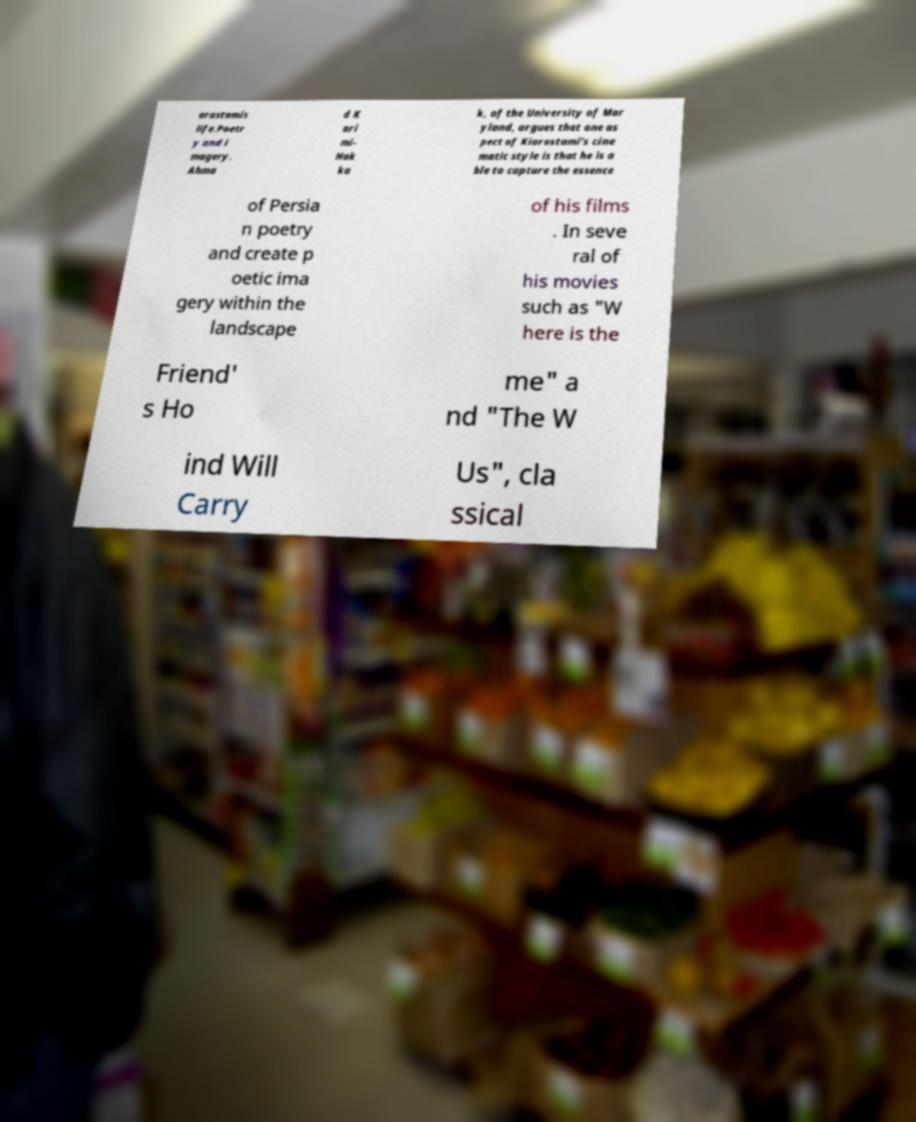Please identify and transcribe the text found in this image. arostamis life.Poetr y and i magery. Ahma d K ari mi- Hak ka k, of the University of Mar yland, argues that one as pect of Kiarostami's cine matic style is that he is a ble to capture the essence of Persia n poetry and create p oetic ima gery within the landscape of his films . In seve ral of his movies such as "W here is the Friend' s Ho me" a nd "The W ind Will Carry Us", cla ssical 